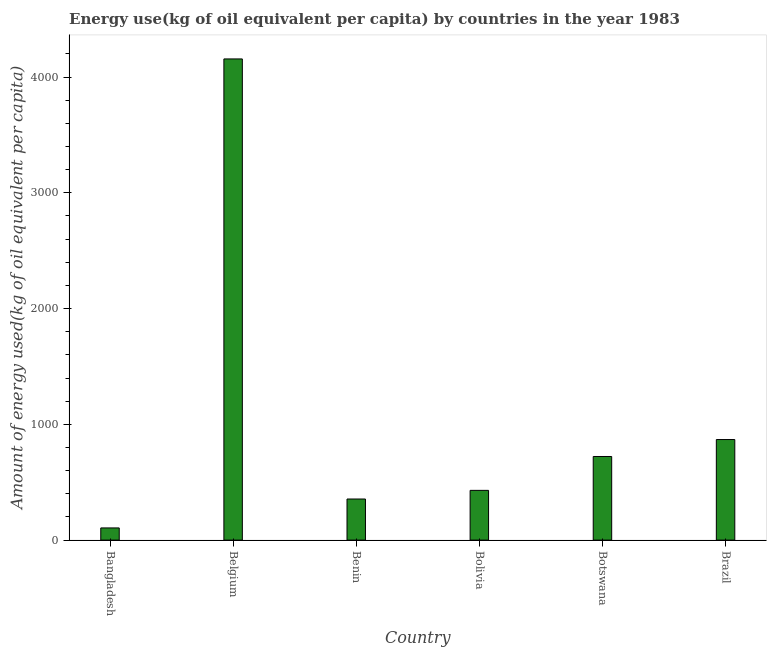Does the graph contain any zero values?
Provide a short and direct response. No. What is the title of the graph?
Make the answer very short. Energy use(kg of oil equivalent per capita) by countries in the year 1983. What is the label or title of the Y-axis?
Make the answer very short. Amount of energy used(kg of oil equivalent per capita). What is the amount of energy used in Bangladesh?
Ensure brevity in your answer.  105.17. Across all countries, what is the maximum amount of energy used?
Your answer should be compact. 4156.26. Across all countries, what is the minimum amount of energy used?
Your answer should be very brief. 105.17. In which country was the amount of energy used minimum?
Ensure brevity in your answer.  Bangladesh. What is the sum of the amount of energy used?
Give a very brief answer. 6636.83. What is the difference between the amount of energy used in Benin and Brazil?
Your answer should be compact. -513.71. What is the average amount of energy used per country?
Provide a short and direct response. 1106.14. What is the median amount of energy used?
Your answer should be very brief. 575.86. In how many countries, is the amount of energy used greater than 400 kg?
Your answer should be very brief. 4. What is the ratio of the amount of energy used in Botswana to that in Brazil?
Offer a very short reply. 0.83. Is the amount of energy used in Bangladesh less than that in Botswana?
Your answer should be compact. Yes. What is the difference between the highest and the second highest amount of energy used?
Your response must be concise. 3287.56. Is the sum of the amount of energy used in Benin and Bolivia greater than the maximum amount of energy used across all countries?
Your answer should be compact. No. What is the difference between the highest and the lowest amount of energy used?
Offer a terse response. 4051.09. In how many countries, is the amount of energy used greater than the average amount of energy used taken over all countries?
Make the answer very short. 1. Are all the bars in the graph horizontal?
Keep it short and to the point. No. What is the difference between two consecutive major ticks on the Y-axis?
Provide a short and direct response. 1000. Are the values on the major ticks of Y-axis written in scientific E-notation?
Offer a very short reply. No. What is the Amount of energy used(kg of oil equivalent per capita) in Bangladesh?
Your answer should be very brief. 105.17. What is the Amount of energy used(kg of oil equivalent per capita) in Belgium?
Offer a very short reply. 4156.26. What is the Amount of energy used(kg of oil equivalent per capita) of Benin?
Give a very brief answer. 354.99. What is the Amount of energy used(kg of oil equivalent per capita) in Bolivia?
Your answer should be very brief. 429.53. What is the Amount of energy used(kg of oil equivalent per capita) in Botswana?
Ensure brevity in your answer.  722.18. What is the Amount of energy used(kg of oil equivalent per capita) of Brazil?
Ensure brevity in your answer.  868.7. What is the difference between the Amount of energy used(kg of oil equivalent per capita) in Bangladesh and Belgium?
Your answer should be compact. -4051.09. What is the difference between the Amount of energy used(kg of oil equivalent per capita) in Bangladesh and Benin?
Offer a very short reply. -249.81. What is the difference between the Amount of energy used(kg of oil equivalent per capita) in Bangladesh and Bolivia?
Offer a very short reply. -324.36. What is the difference between the Amount of energy used(kg of oil equivalent per capita) in Bangladesh and Botswana?
Make the answer very short. -617.01. What is the difference between the Amount of energy used(kg of oil equivalent per capita) in Bangladesh and Brazil?
Provide a short and direct response. -763.53. What is the difference between the Amount of energy used(kg of oil equivalent per capita) in Belgium and Benin?
Your response must be concise. 3801.27. What is the difference between the Amount of energy used(kg of oil equivalent per capita) in Belgium and Bolivia?
Provide a succinct answer. 3726.73. What is the difference between the Amount of energy used(kg of oil equivalent per capita) in Belgium and Botswana?
Provide a succinct answer. 3434.07. What is the difference between the Amount of energy used(kg of oil equivalent per capita) in Belgium and Brazil?
Your answer should be compact. 3287.56. What is the difference between the Amount of energy used(kg of oil equivalent per capita) in Benin and Bolivia?
Give a very brief answer. -74.54. What is the difference between the Amount of energy used(kg of oil equivalent per capita) in Benin and Botswana?
Your answer should be compact. -367.2. What is the difference between the Amount of energy used(kg of oil equivalent per capita) in Benin and Brazil?
Provide a short and direct response. -513.71. What is the difference between the Amount of energy used(kg of oil equivalent per capita) in Bolivia and Botswana?
Make the answer very short. -292.66. What is the difference between the Amount of energy used(kg of oil equivalent per capita) in Bolivia and Brazil?
Your response must be concise. -439.17. What is the difference between the Amount of energy used(kg of oil equivalent per capita) in Botswana and Brazil?
Make the answer very short. -146.51. What is the ratio of the Amount of energy used(kg of oil equivalent per capita) in Bangladesh to that in Belgium?
Provide a short and direct response. 0.03. What is the ratio of the Amount of energy used(kg of oil equivalent per capita) in Bangladesh to that in Benin?
Your answer should be very brief. 0.3. What is the ratio of the Amount of energy used(kg of oil equivalent per capita) in Bangladesh to that in Bolivia?
Your answer should be compact. 0.24. What is the ratio of the Amount of energy used(kg of oil equivalent per capita) in Bangladesh to that in Botswana?
Make the answer very short. 0.15. What is the ratio of the Amount of energy used(kg of oil equivalent per capita) in Bangladesh to that in Brazil?
Your answer should be very brief. 0.12. What is the ratio of the Amount of energy used(kg of oil equivalent per capita) in Belgium to that in Benin?
Offer a very short reply. 11.71. What is the ratio of the Amount of energy used(kg of oil equivalent per capita) in Belgium to that in Bolivia?
Keep it short and to the point. 9.68. What is the ratio of the Amount of energy used(kg of oil equivalent per capita) in Belgium to that in Botswana?
Offer a terse response. 5.75. What is the ratio of the Amount of energy used(kg of oil equivalent per capita) in Belgium to that in Brazil?
Make the answer very short. 4.78. What is the ratio of the Amount of energy used(kg of oil equivalent per capita) in Benin to that in Bolivia?
Provide a short and direct response. 0.83. What is the ratio of the Amount of energy used(kg of oil equivalent per capita) in Benin to that in Botswana?
Your answer should be very brief. 0.49. What is the ratio of the Amount of energy used(kg of oil equivalent per capita) in Benin to that in Brazil?
Your response must be concise. 0.41. What is the ratio of the Amount of energy used(kg of oil equivalent per capita) in Bolivia to that in Botswana?
Provide a short and direct response. 0.59. What is the ratio of the Amount of energy used(kg of oil equivalent per capita) in Bolivia to that in Brazil?
Your answer should be compact. 0.49. What is the ratio of the Amount of energy used(kg of oil equivalent per capita) in Botswana to that in Brazil?
Keep it short and to the point. 0.83. 